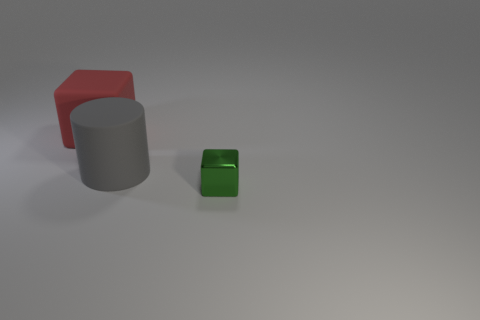What number of things are either objects left of the small metal cube or large rubber objects?
Your response must be concise. 2. Is the number of green shiny things the same as the number of large purple objects?
Give a very brief answer. No. There is another large object that is the same material as the big red thing; what is its shape?
Your response must be concise. Cylinder. The red thing has what shape?
Provide a succinct answer. Cube. There is a object that is both in front of the red rubber object and to the left of the tiny cube; what is its color?
Your response must be concise. Gray. What shape is the red rubber object that is the same size as the gray matte object?
Offer a terse response. Cube. Is there another small red matte thing of the same shape as the red matte thing?
Your response must be concise. No. Are the red cube and the block to the right of the large gray object made of the same material?
Your answer should be compact. No. The large object that is behind the big cylinder on the right side of the matte object behind the large gray rubber object is what color?
Ensure brevity in your answer.  Red. There is a cube that is the same size as the gray cylinder; what material is it?
Give a very brief answer. Rubber. 